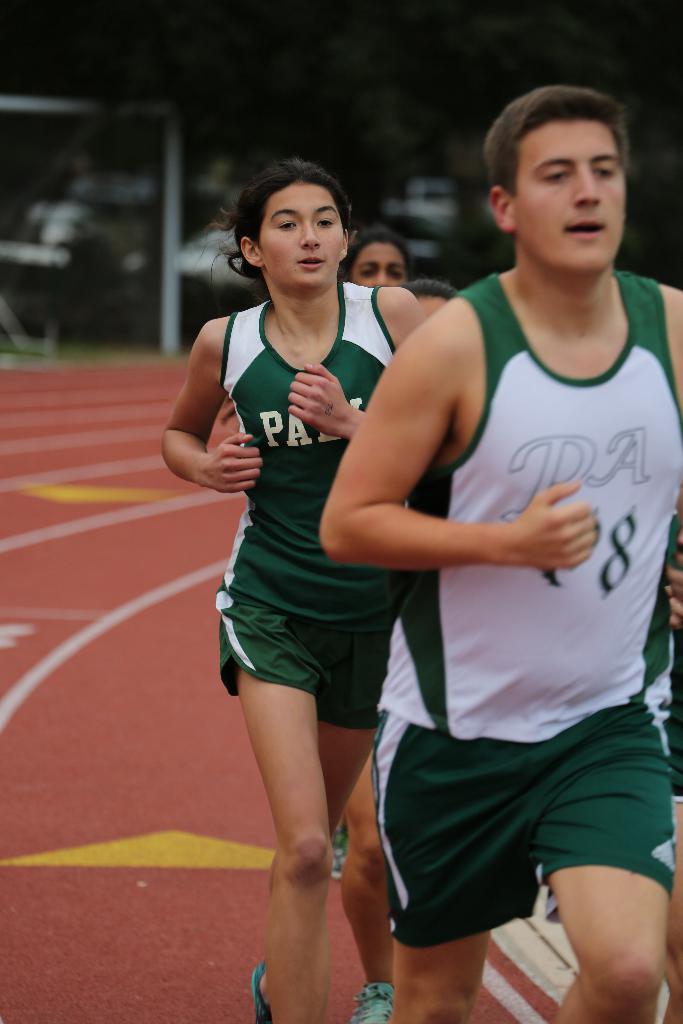What is the second number on the right athlete's jersey?
Make the answer very short. 8. 